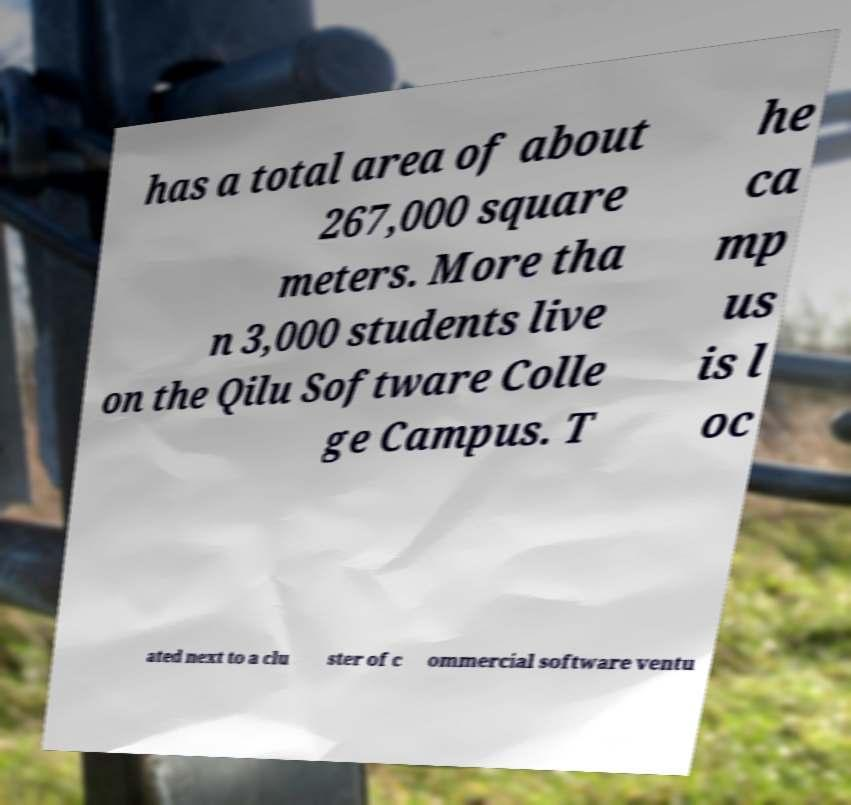I need the written content from this picture converted into text. Can you do that? has a total area of about 267,000 square meters. More tha n 3,000 students live on the Qilu Software Colle ge Campus. T he ca mp us is l oc ated next to a clu ster of c ommercial software ventu 